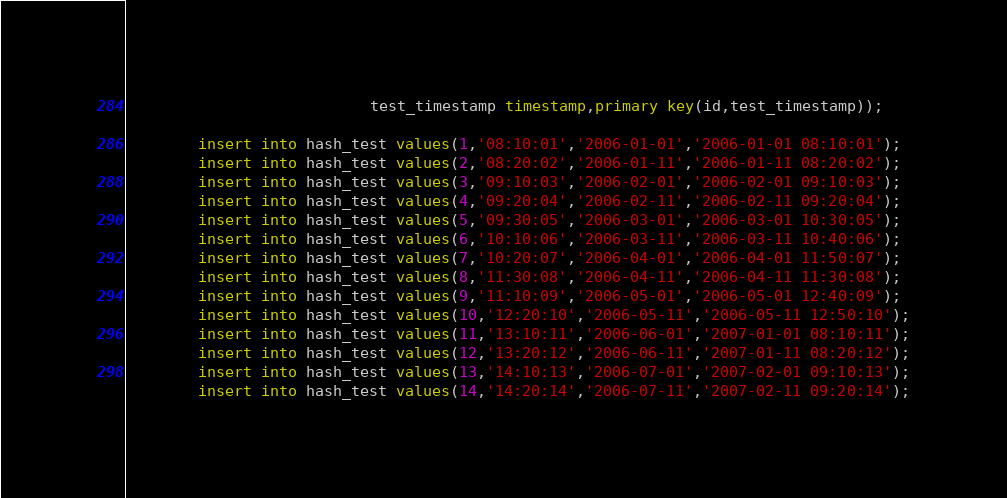Convert code to text. <code><loc_0><loc_0><loc_500><loc_500><_SQL_>                           test_timestamp timestamp,primary key(id,test_timestamp));

        insert into hash_test values(1,'08:10:01','2006-01-01','2006-01-01 08:10:01');
        insert into hash_test values(2,'08:20:02','2006-01-11','2006-01-11 08:20:02');
        insert into hash_test values(3,'09:10:03','2006-02-01','2006-02-01 09:10:03');
        insert into hash_test values(4,'09:20:04','2006-02-11','2006-02-11 09:20:04');
        insert into hash_test values(5,'09:30:05','2006-03-01','2006-03-01 10:30:05');
        insert into hash_test values(6,'10:10:06','2006-03-11','2006-03-11 10:40:06');
        insert into hash_test values(7,'10:20:07','2006-04-01','2006-04-01 11:50:07');
        insert into hash_test values(8,'11:30:08','2006-04-11','2006-04-11 11:30:08');
        insert into hash_test values(9,'11:10:09','2006-05-01','2006-05-01 12:40:09');
        insert into hash_test values(10,'12:20:10','2006-05-11','2006-05-11 12:50:10');
        insert into hash_test values(11,'13:10:11','2006-06-01','2007-01-01 08:10:11');
        insert into hash_test values(12,'13:20:12','2006-06-11','2007-01-11 08:20:12');
        insert into hash_test values(13,'14:10:13','2006-07-01','2007-02-01 09:10:13');
        insert into hash_test values(14,'14:20:14','2006-07-11','2007-02-11 09:20:14');</code> 